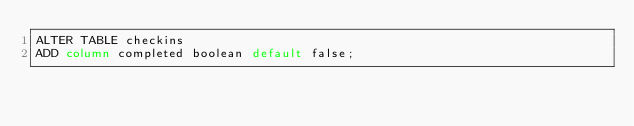<code> <loc_0><loc_0><loc_500><loc_500><_SQL_>ALTER TABLE checkins
ADD column completed boolean default false;</code> 